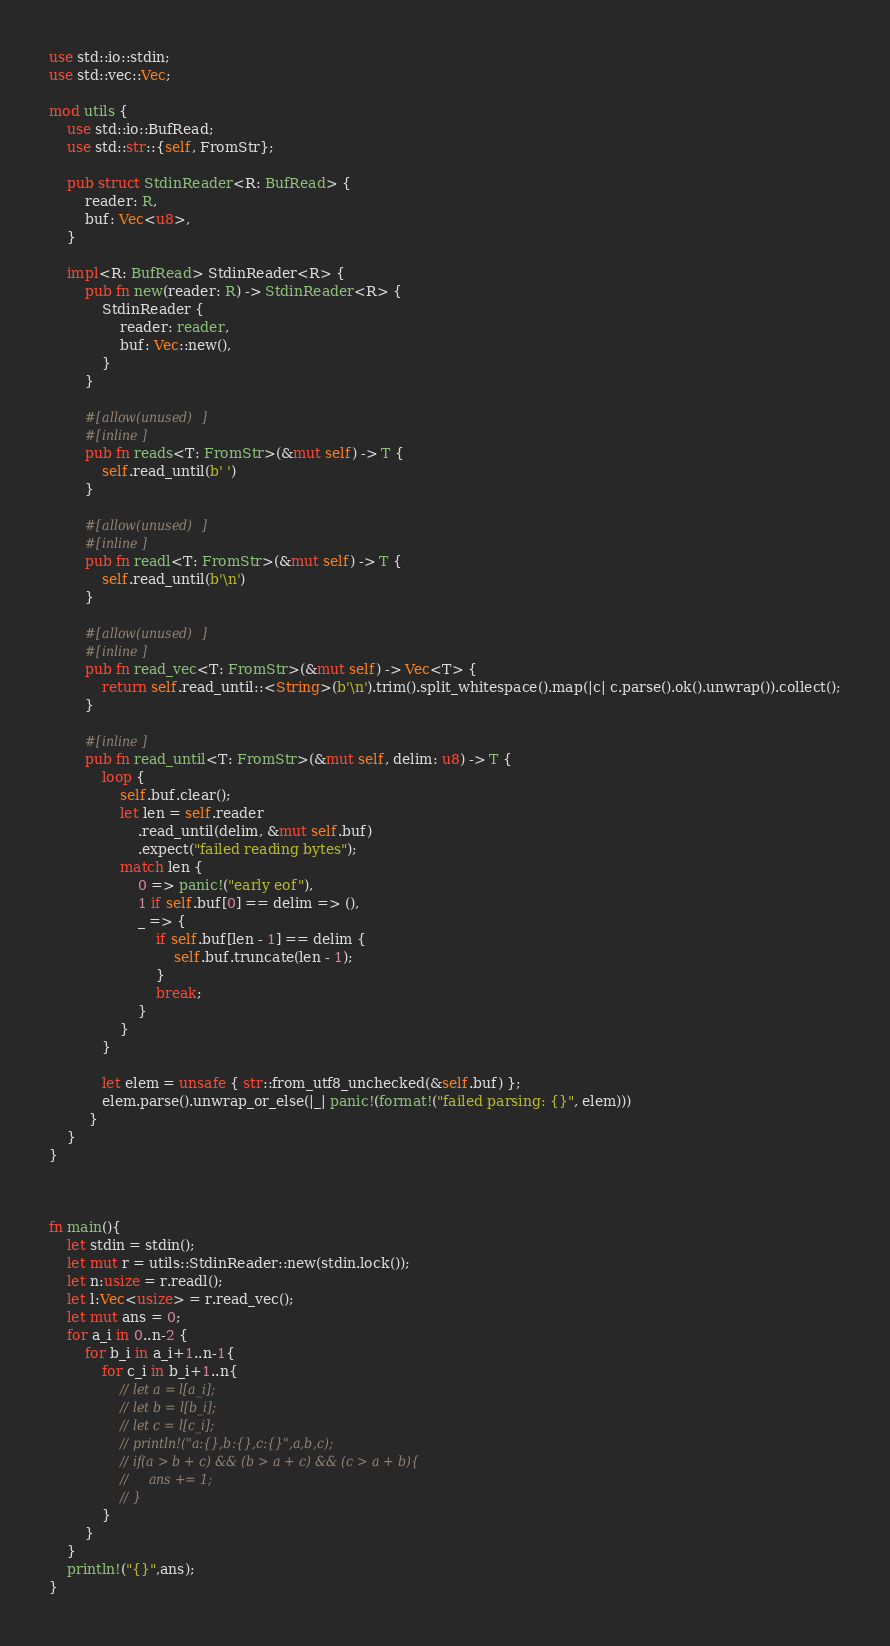Convert code to text. <code><loc_0><loc_0><loc_500><loc_500><_Rust_>use std::io::stdin;
use std::vec::Vec;

mod utils {
    use std::io::BufRead;
    use std::str::{self, FromStr};

    pub struct StdinReader<R: BufRead> {
        reader: R,
        buf: Vec<u8>,
    }

    impl<R: BufRead> StdinReader<R> {
        pub fn new(reader: R) -> StdinReader<R> {
            StdinReader {
                reader: reader,
                buf: Vec::new(),
            }
        }

        #[allow(unused)]
        #[inline]
        pub fn reads<T: FromStr>(&mut self) -> T {
            self.read_until(b' ')
        }

        #[allow(unused)]
        #[inline]
        pub fn readl<T: FromStr>(&mut self) -> T {
            self.read_until(b'\n')
        }

        #[allow(unused)]
        #[inline]
        pub fn read_vec<T: FromStr>(&mut self) -> Vec<T> {
            return self.read_until::<String>(b'\n').trim().split_whitespace().map(|c| c.parse().ok().unwrap()).collect();
        }

        #[inline]
        pub fn read_until<T: FromStr>(&mut self, delim: u8) -> T {
            loop {
                self.buf.clear();
                let len = self.reader
                    .read_until(delim, &mut self.buf)
                    .expect("failed reading bytes");
                match len {
                    0 => panic!("early eof"),
                    1 if self.buf[0] == delim => (),
                    _ => {
                        if self.buf[len - 1] == delim {
                            self.buf.truncate(len - 1);
                        }
                        break;
                    }
                }
            }

            let elem = unsafe { str::from_utf8_unchecked(&self.buf) };
            elem.parse().unwrap_or_else(|_| panic!(format!("failed parsing: {}", elem)))
         }
    }
}



fn main(){
    let stdin = stdin();
    let mut r = utils::StdinReader::new(stdin.lock());
    let n:usize = r.readl();
    let l:Vec<usize> = r.read_vec();
    let mut ans = 0;
    for a_i in 0..n-2 {
        for b_i in a_i+1..n-1{
            for c_i in b_i+1..n{
                // let a = l[a_i];
                // let b = l[b_i];
                // let c = l[c_i];
                // println!("a:{},b:{},c:{}",a,b,c);
                // if(a > b + c) && (b > a + c) && (c > a + b){
                //     ans += 1;
                // }
            }
        }
    }
    println!("{}",ans);
}
</code> 